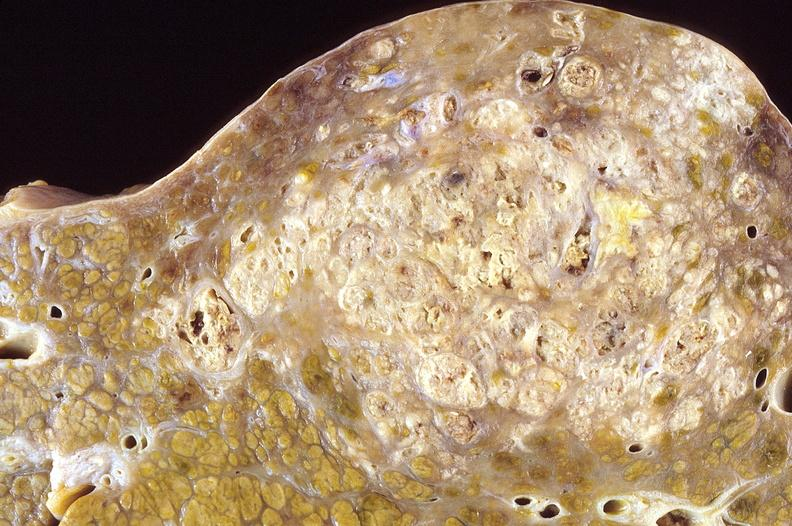what is present?
Answer the question using a single word or phrase. Liver 